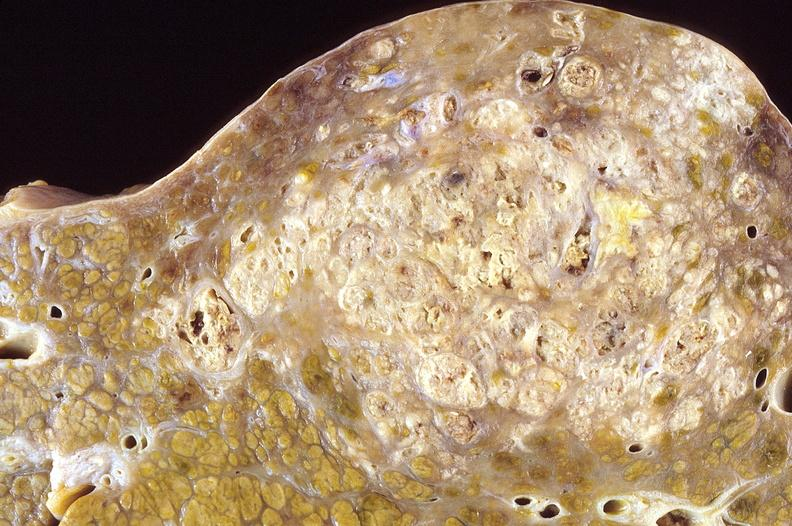what is present?
Answer the question using a single word or phrase. Liver 